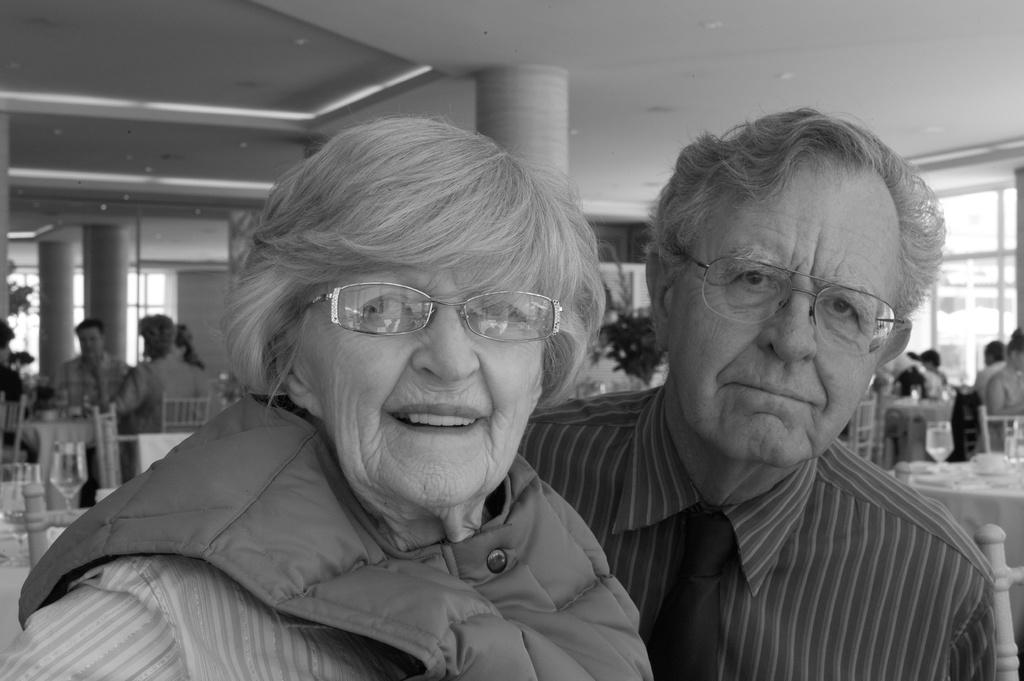Who are the main subjects in the image? There is an old woman and an old man in the image. What are the old woman and the old man doing? Both the old woman and the old man are looking at someone. Can you describe the setting in the background of the image? There are people sitting on chairs and a table in the background of the image. How many cows can be seen in the image? There are no cows present in the image. What type of person is sitting on the chair in the image? The image does not specify the type of person sitting on the chair; it only shows people sitting on chairs in the background. 